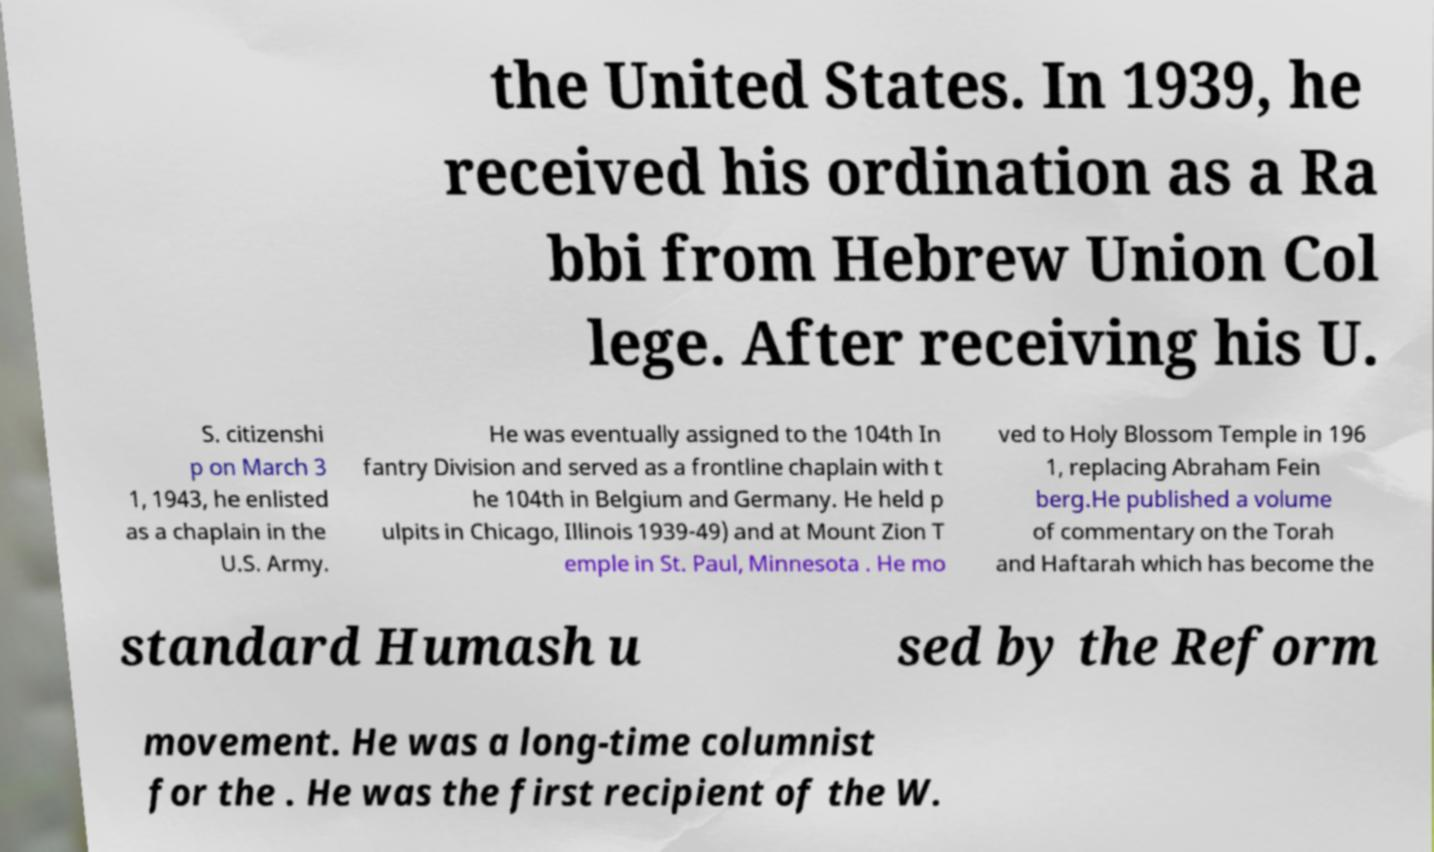Please identify and transcribe the text found in this image. the United States. In 1939, he received his ordination as a Ra bbi from Hebrew Union Col lege. After receiving his U. S. citizenshi p on March 3 1, 1943, he enlisted as a chaplain in the U.S. Army. He was eventually assigned to the 104th In fantry Division and served as a frontline chaplain with t he 104th in Belgium and Germany. He held p ulpits in Chicago, Illinois 1939-49) and at Mount Zion T emple in St. Paul, Minnesota . He mo ved to Holy Blossom Temple in 196 1, replacing Abraham Fein berg.He published a volume of commentary on the Torah and Haftarah which has become the standard Humash u sed by the Reform movement. He was a long-time columnist for the . He was the first recipient of the W. 